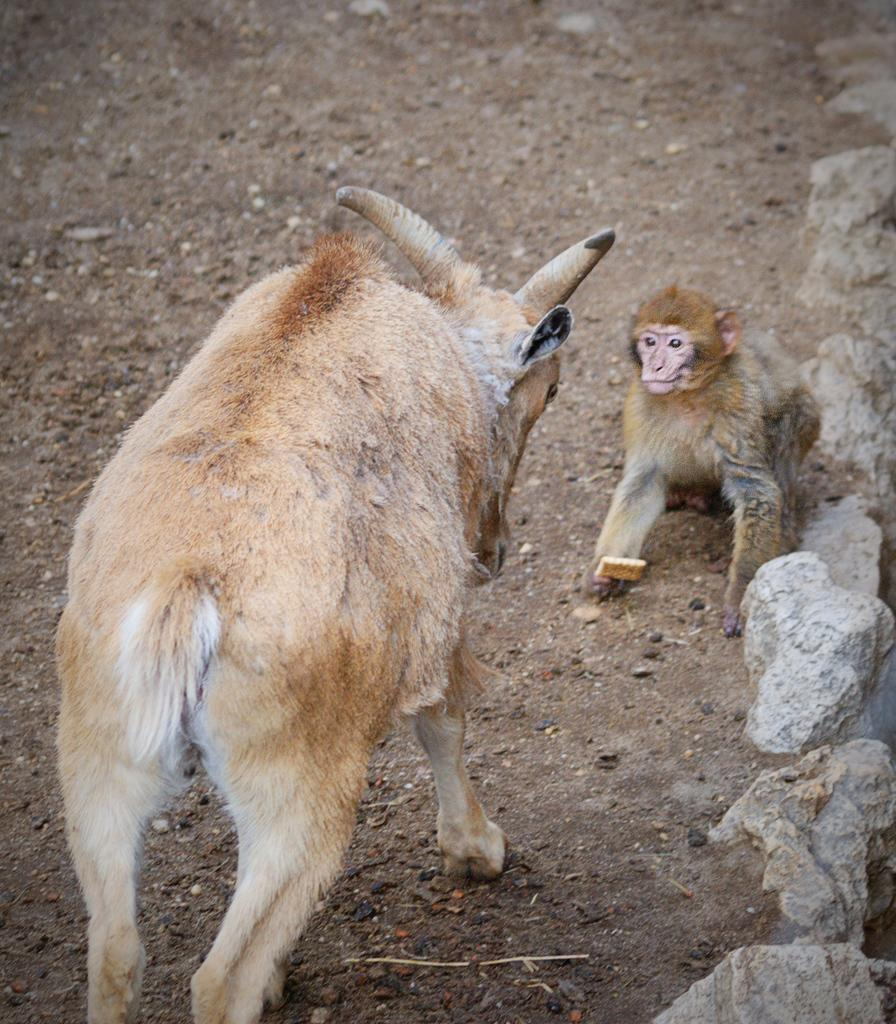What type of animal is in the image? There is a goat in the image. Can you describe the color of the goat? The goat is cream-colored. What other animal is present in the image? There is a monkey in the image. How is the monkey positioned in relation to the goat? The monkey is in front of the goat. Where are the goat and the monkey located? Both the goat and the monkey are on the land. What can be seen on the right side of the image? There are stones visible on the right side of the image. What type of songs can be heard being sung by the goat in the image? There are no songs being sung by the goat in the image, as goats do not have the ability to sing. 